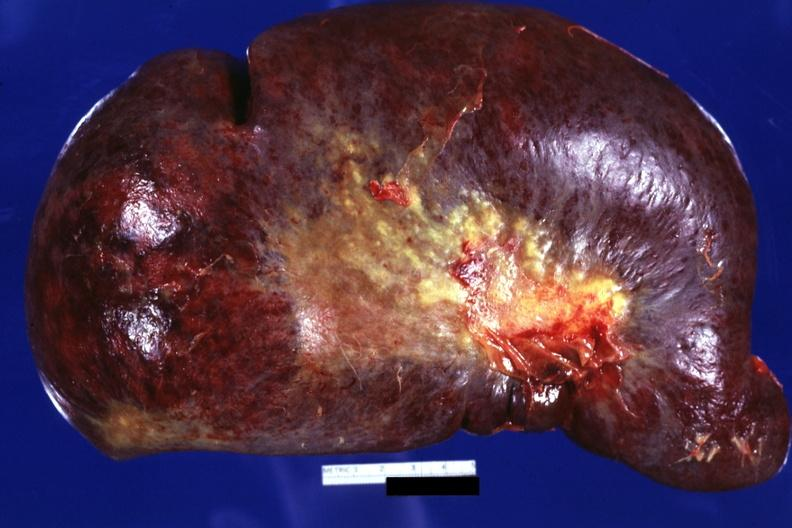what is present?
Answer the question using a single word or phrase. Splenomegaly with cirrhosis 